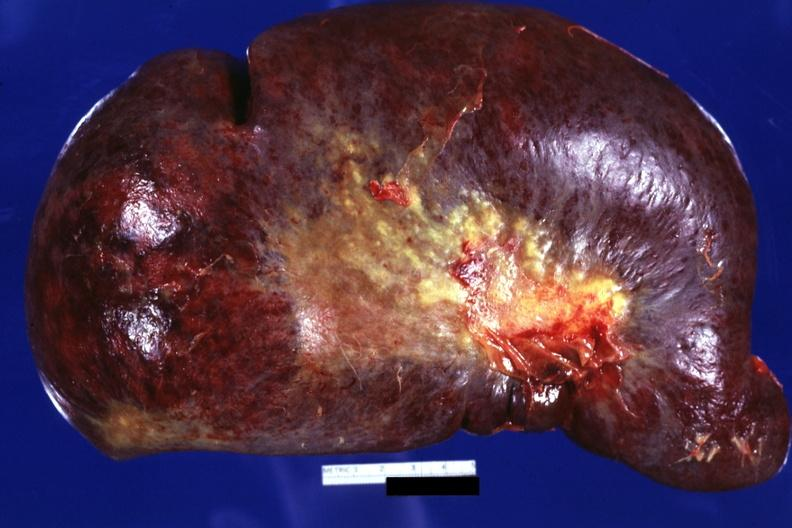what is present?
Answer the question using a single word or phrase. Splenomegaly with cirrhosis 